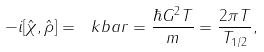<formula> <loc_0><loc_0><loc_500><loc_500>- i [ \hat { \chi } , \hat { \rho } ] = \ k b a r = \frac { \hbar { G } ^ { 2 } T } { m } = \frac { 2 \pi T } { T _ { 1 / 2 } } ,</formula> 